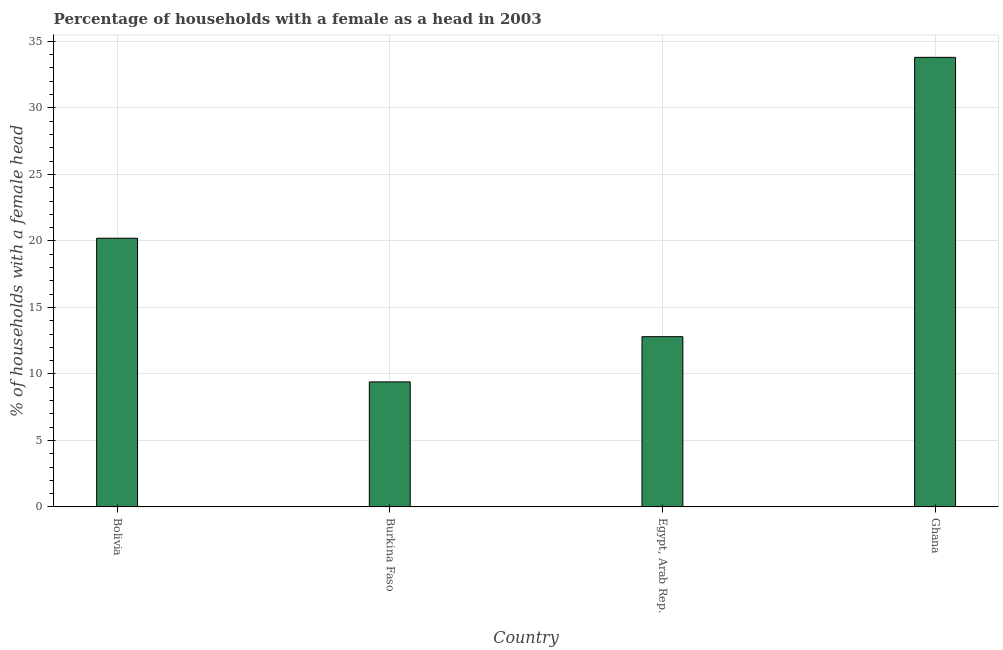Does the graph contain grids?
Your response must be concise. Yes. What is the title of the graph?
Your answer should be compact. Percentage of households with a female as a head in 2003. What is the label or title of the Y-axis?
Make the answer very short. % of households with a female head. Across all countries, what is the maximum number of female supervised households?
Keep it short and to the point. 33.8. Across all countries, what is the minimum number of female supervised households?
Your response must be concise. 9.4. In which country was the number of female supervised households minimum?
Offer a terse response. Burkina Faso. What is the sum of the number of female supervised households?
Offer a terse response. 76.2. What is the difference between the number of female supervised households in Burkina Faso and Ghana?
Keep it short and to the point. -24.4. What is the average number of female supervised households per country?
Provide a succinct answer. 19.05. What is the median number of female supervised households?
Make the answer very short. 16.5. In how many countries, is the number of female supervised households greater than 8 %?
Your answer should be very brief. 4. What is the ratio of the number of female supervised households in Egypt, Arab Rep. to that in Ghana?
Ensure brevity in your answer.  0.38. Is the number of female supervised households in Burkina Faso less than that in Ghana?
Offer a very short reply. Yes. Is the sum of the number of female supervised households in Bolivia and Egypt, Arab Rep. greater than the maximum number of female supervised households across all countries?
Make the answer very short. No. What is the difference between the highest and the lowest number of female supervised households?
Provide a short and direct response. 24.4. In how many countries, is the number of female supervised households greater than the average number of female supervised households taken over all countries?
Ensure brevity in your answer.  2. How many bars are there?
Your answer should be very brief. 4. Are all the bars in the graph horizontal?
Your answer should be very brief. No. How many countries are there in the graph?
Provide a succinct answer. 4. What is the difference between two consecutive major ticks on the Y-axis?
Offer a terse response. 5. Are the values on the major ticks of Y-axis written in scientific E-notation?
Your answer should be very brief. No. What is the % of households with a female head of Bolivia?
Your response must be concise. 20.2. What is the % of households with a female head in Ghana?
Your answer should be very brief. 33.8. What is the difference between the % of households with a female head in Bolivia and Burkina Faso?
Your answer should be compact. 10.8. What is the difference between the % of households with a female head in Bolivia and Ghana?
Offer a very short reply. -13.6. What is the difference between the % of households with a female head in Burkina Faso and Ghana?
Make the answer very short. -24.4. What is the difference between the % of households with a female head in Egypt, Arab Rep. and Ghana?
Offer a terse response. -21. What is the ratio of the % of households with a female head in Bolivia to that in Burkina Faso?
Ensure brevity in your answer.  2.15. What is the ratio of the % of households with a female head in Bolivia to that in Egypt, Arab Rep.?
Your answer should be compact. 1.58. What is the ratio of the % of households with a female head in Bolivia to that in Ghana?
Provide a short and direct response. 0.6. What is the ratio of the % of households with a female head in Burkina Faso to that in Egypt, Arab Rep.?
Keep it short and to the point. 0.73. What is the ratio of the % of households with a female head in Burkina Faso to that in Ghana?
Your answer should be very brief. 0.28. What is the ratio of the % of households with a female head in Egypt, Arab Rep. to that in Ghana?
Your answer should be compact. 0.38. 